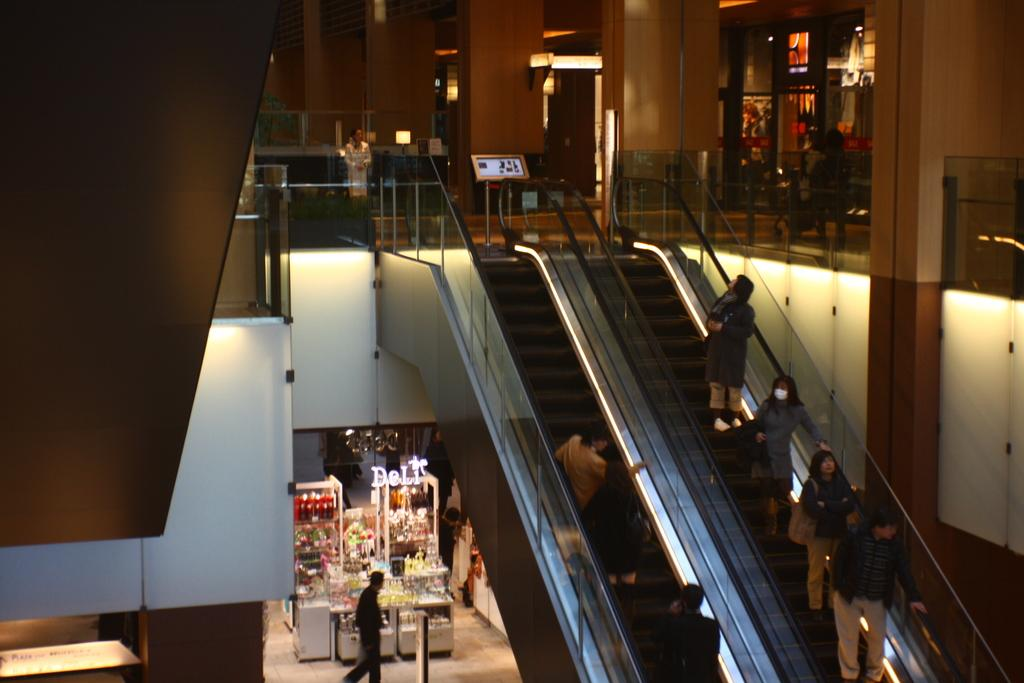What are the people in the image doing? The people in the image are standing on escalators. What can be seen in the background of the image? In the background of the image, there is a wall, pillars, lights, products, and other objects. Can you describe the escalators in the image? The escalators are moving staircases that the people are standing on. What type of power does the bottle provide in the image? There is no bottle present in the image, so it cannot provide any power. 